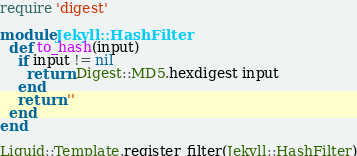<code> <loc_0><loc_0><loc_500><loc_500><_Ruby_>require 'digest'

module Jekyll::HashFilter
  def to_hash(input)
    if input != nil
      return Digest::MD5.hexdigest input
    end
    return ''
  end
end

Liquid::Template.register_filter(Jekyll::HashFilter)</code> 